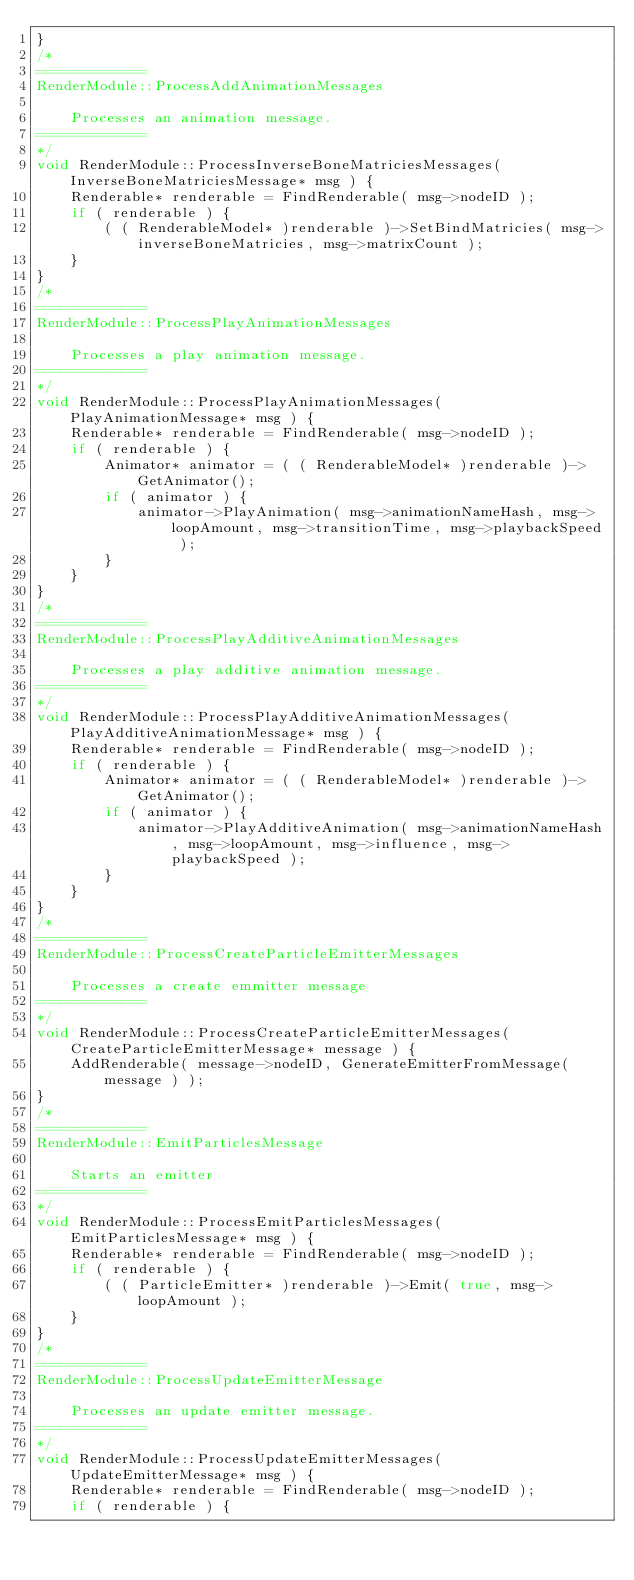<code> <loc_0><loc_0><loc_500><loc_500><_C++_>}
/*
=============
RenderModule::ProcessAddAnimationMessages

	Processes an animation message.
=============
*/
void RenderModule::ProcessInverseBoneMatriciesMessages( InverseBoneMatriciesMessage* msg ) {
	Renderable* renderable = FindRenderable( msg->nodeID );
	if ( renderable ) {
		( ( RenderableModel* )renderable )->SetBindMatricies( msg->inverseBoneMatricies, msg->matrixCount );
	}
}
/*
=============
RenderModule::ProcessPlayAnimationMessages

	Processes a play animation message.
=============
*/
void RenderModule::ProcessPlayAnimationMessages( PlayAnimationMessage* msg ) {
	Renderable* renderable = FindRenderable( msg->nodeID );
	if ( renderable ) {
		Animator* animator = ( ( RenderableModel* )renderable )->GetAnimator();
		if ( animator ) {
			animator->PlayAnimation( msg->animationNameHash, msg->loopAmount, msg->transitionTime, msg->playbackSpeed );
		}
	}
}
/*
=============
RenderModule::ProcessPlayAdditiveAnimationMessages

	Processes a play additive animation message.
=============
*/
void RenderModule::ProcessPlayAdditiveAnimationMessages( PlayAdditiveAnimationMessage* msg ) {
	Renderable* renderable = FindRenderable( msg->nodeID );
	if ( renderable ) {
		Animator* animator = ( ( RenderableModel* )renderable )->GetAnimator();
		if ( animator ) {
			animator->PlayAdditiveAnimation( msg->animationNameHash, msg->loopAmount, msg->influence, msg->playbackSpeed );
		}
	}
}
/*
=============
RenderModule::ProcessCreateParticleEmitterMessages

	Processes a create emmitter message
=============
*/
void RenderModule::ProcessCreateParticleEmitterMessages( CreateParticleEmitterMessage* message ) {
	AddRenderable( message->nodeID, GenerateEmitterFromMessage( message ) );
}
/*
=============
RenderModule::EmitParticlesMessage

	Starts an emitter
=============
*/
void RenderModule::ProcessEmitParticlesMessages( EmitParticlesMessage* msg ) {
	Renderable* renderable = FindRenderable( msg->nodeID );
	if ( renderable ) {
		( ( ParticleEmitter* )renderable )->Emit( true, msg->loopAmount );
	}
}
/*
=============
RenderModule::ProcessUpdateEmitterMessage

	Processes an update emitter message.
=============
*/
void RenderModule::ProcessUpdateEmitterMessages( UpdateEmitterMessage* msg ) {
	Renderable* renderable = FindRenderable( msg->nodeID );
	if ( renderable ) {</code> 